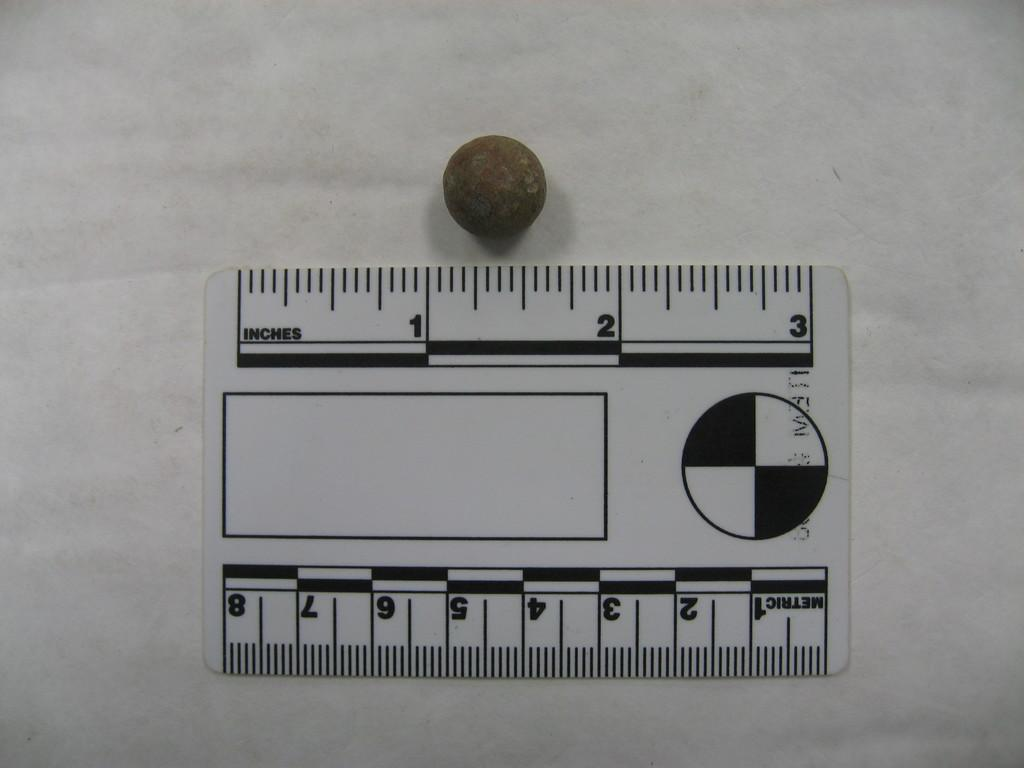<image>
Offer a succinct explanation of the picture presented. A ruler is labeled inches on one side and metric on the other side. 